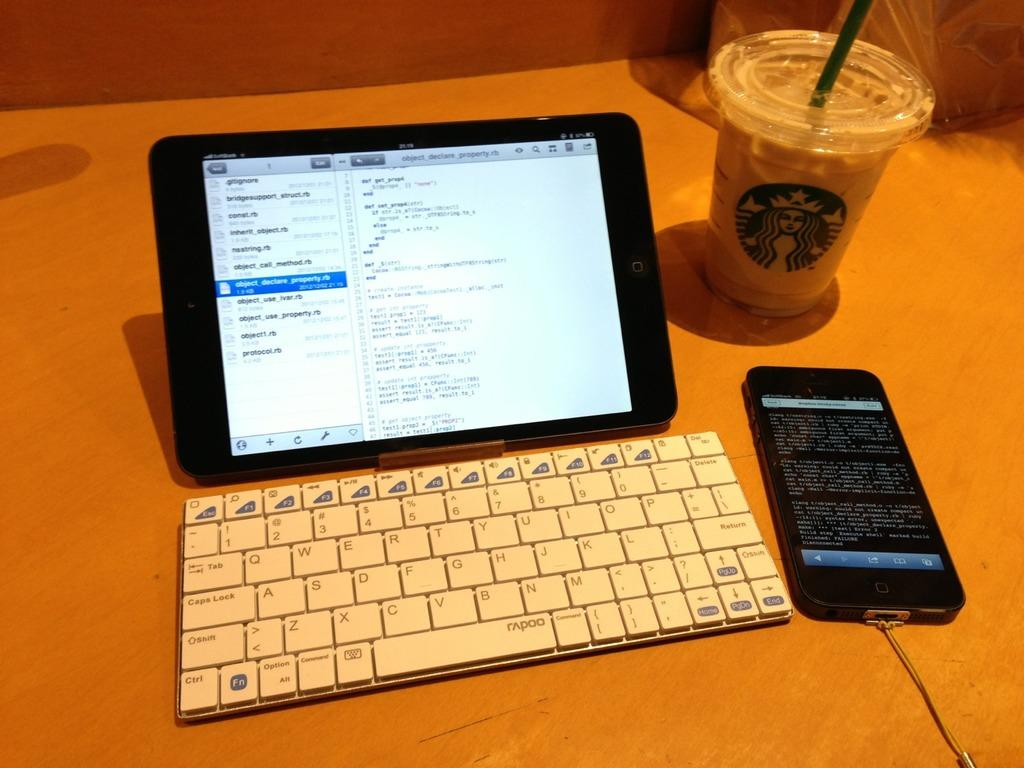What is the main object in the center of the image? There is an electronic device in the center of the image. What is used for typing or inputting commands in the image? There is a keyboard in the image. What type of communication device is present in the image? There is a mobile phone in the image. What is being used for drinking in the image? There is a glass of drink with a straw in the image. Can you describe any other objects in the image? There are some other objects in the image, but their specific details are not mentioned in the provided facts. Where is the volcano located in the image? There is no volcano present in the image. What type of cow can be seen grazing in the image? There is no cow present in the image. 